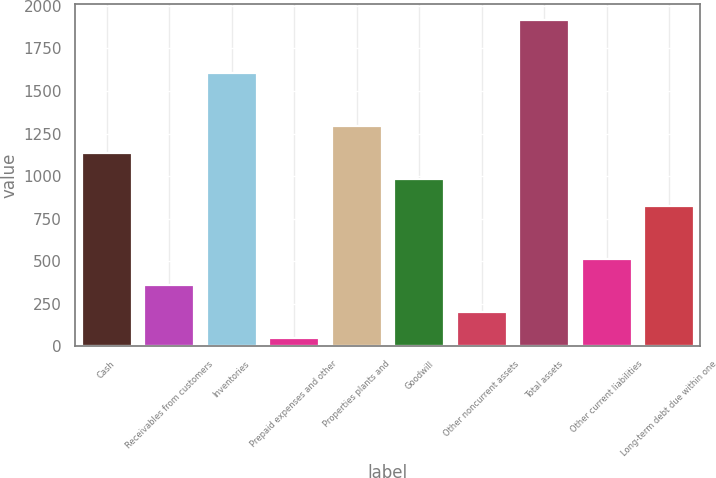Convert chart. <chart><loc_0><loc_0><loc_500><loc_500><bar_chart><fcel>Cash<fcel>Receivables from customers<fcel>Inventories<fcel>Prepaid expenses and other<fcel>Properties plants and<fcel>Goodwill<fcel>Other noncurrent assets<fcel>Total assets<fcel>Other current liabilities<fcel>Long-term debt due within one<nl><fcel>1138.3<fcel>358.8<fcel>1606<fcel>47<fcel>1294.2<fcel>982.4<fcel>202.9<fcel>1917.8<fcel>514.7<fcel>826.5<nl></chart> 